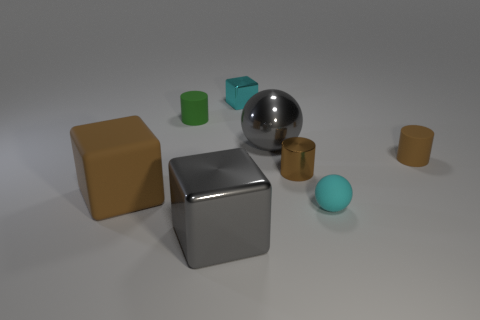Add 1 tiny cyan things. How many objects exist? 9 Subtract all cylinders. How many objects are left? 5 Add 8 green balls. How many green balls exist? 8 Subtract 1 cyan blocks. How many objects are left? 7 Subtract all large brown blocks. Subtract all gray shiny things. How many objects are left? 5 Add 4 tiny cylinders. How many tiny cylinders are left? 7 